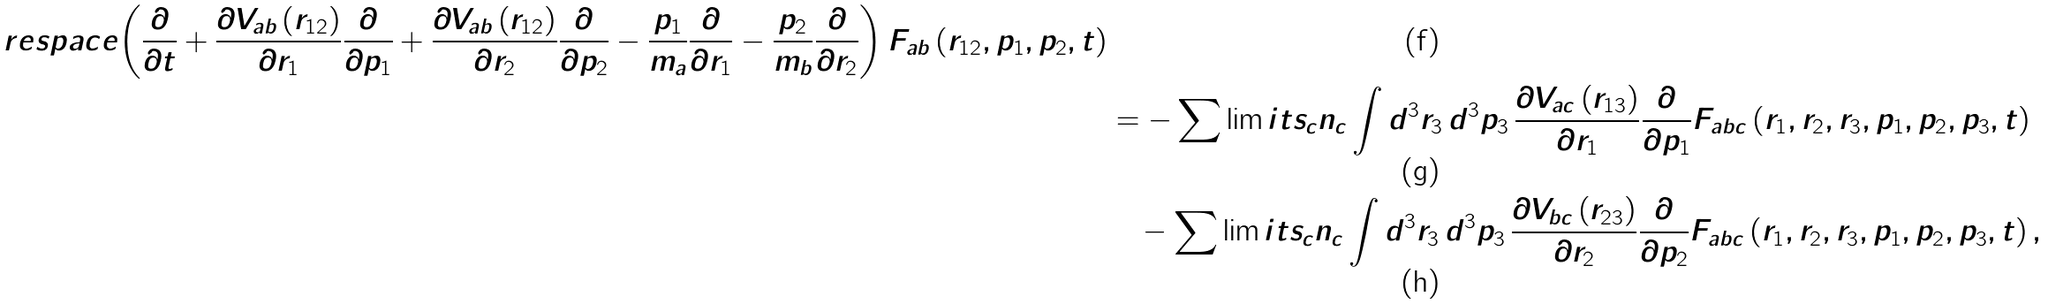<formula> <loc_0><loc_0><loc_500><loc_500>\ r e s p a c e { \left ( \frac { \partial } { \partial t } + \frac { \partial V _ { a b } \left ( r _ { 1 2 } \right ) } { \partial r _ { 1 } } \frac { \partial } { \partial p _ { 1 } } + \frac { \partial V _ { a b } \left ( r _ { 1 2 } \right ) } { \partial r _ { 2 } } \frac { \partial } { \partial p _ { 2 } } - \frac { p _ { 1 } } { m _ { a } } \frac { \partial } { \partial r _ { 1 } } - \frac { p _ { 2 } } { m _ { b } } \frac { \partial } { \partial r _ { 2 } } \right ) F _ { a b } \left ( r _ { 1 2 } , p _ { 1 } , p _ { 2 } , t \right ) } \\ & = - \sum \lim i t s _ { c } n _ { c } \int d ^ { 3 } r _ { 3 } \, d ^ { 3 } p _ { 3 } \, \frac { \partial V _ { a c } \left ( r _ { 1 3 } \right ) } { \partial r _ { 1 } } \frac { \partial } { \partial p _ { 1 } } F _ { a b c } \left ( r _ { 1 } , r _ { 2 } , r _ { 3 } , p _ { 1 } , p _ { 2 } , p _ { 3 } , t \right ) \\ & \quad - \sum \lim i t s _ { c } n _ { c } \int d ^ { 3 } r _ { 3 } \, d ^ { 3 } p _ { 3 } \, \frac { \partial V _ { b c } \left ( r _ { 2 3 } \right ) } { \partial r _ { 2 } } \frac { \partial } { \partial p _ { 2 } } F _ { a b c } \left ( r _ { 1 } , r _ { 2 } , r _ { 3 } , p _ { 1 } , p _ { 2 } , p _ { 3 } , t \right ) ,</formula> 